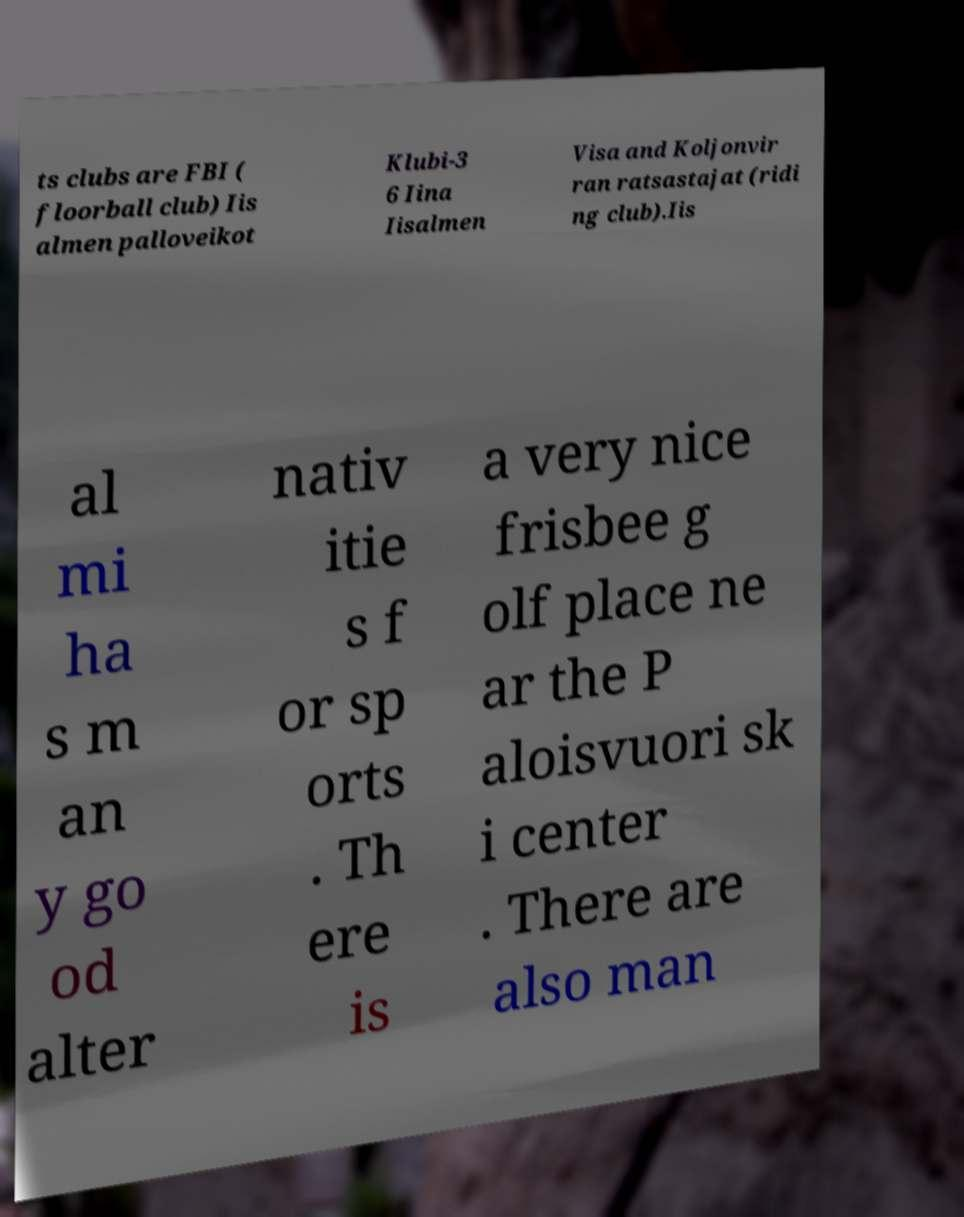Please identify and transcribe the text found in this image. ts clubs are FBI ( floorball club) Iis almen palloveikot Klubi-3 6 Iina Iisalmen Visa and Koljonvir ran ratsastajat (ridi ng club).Iis al mi ha s m an y go od alter nativ itie s f or sp orts . Th ere is a very nice frisbee g olf place ne ar the P aloisvuori sk i center . There are also man 